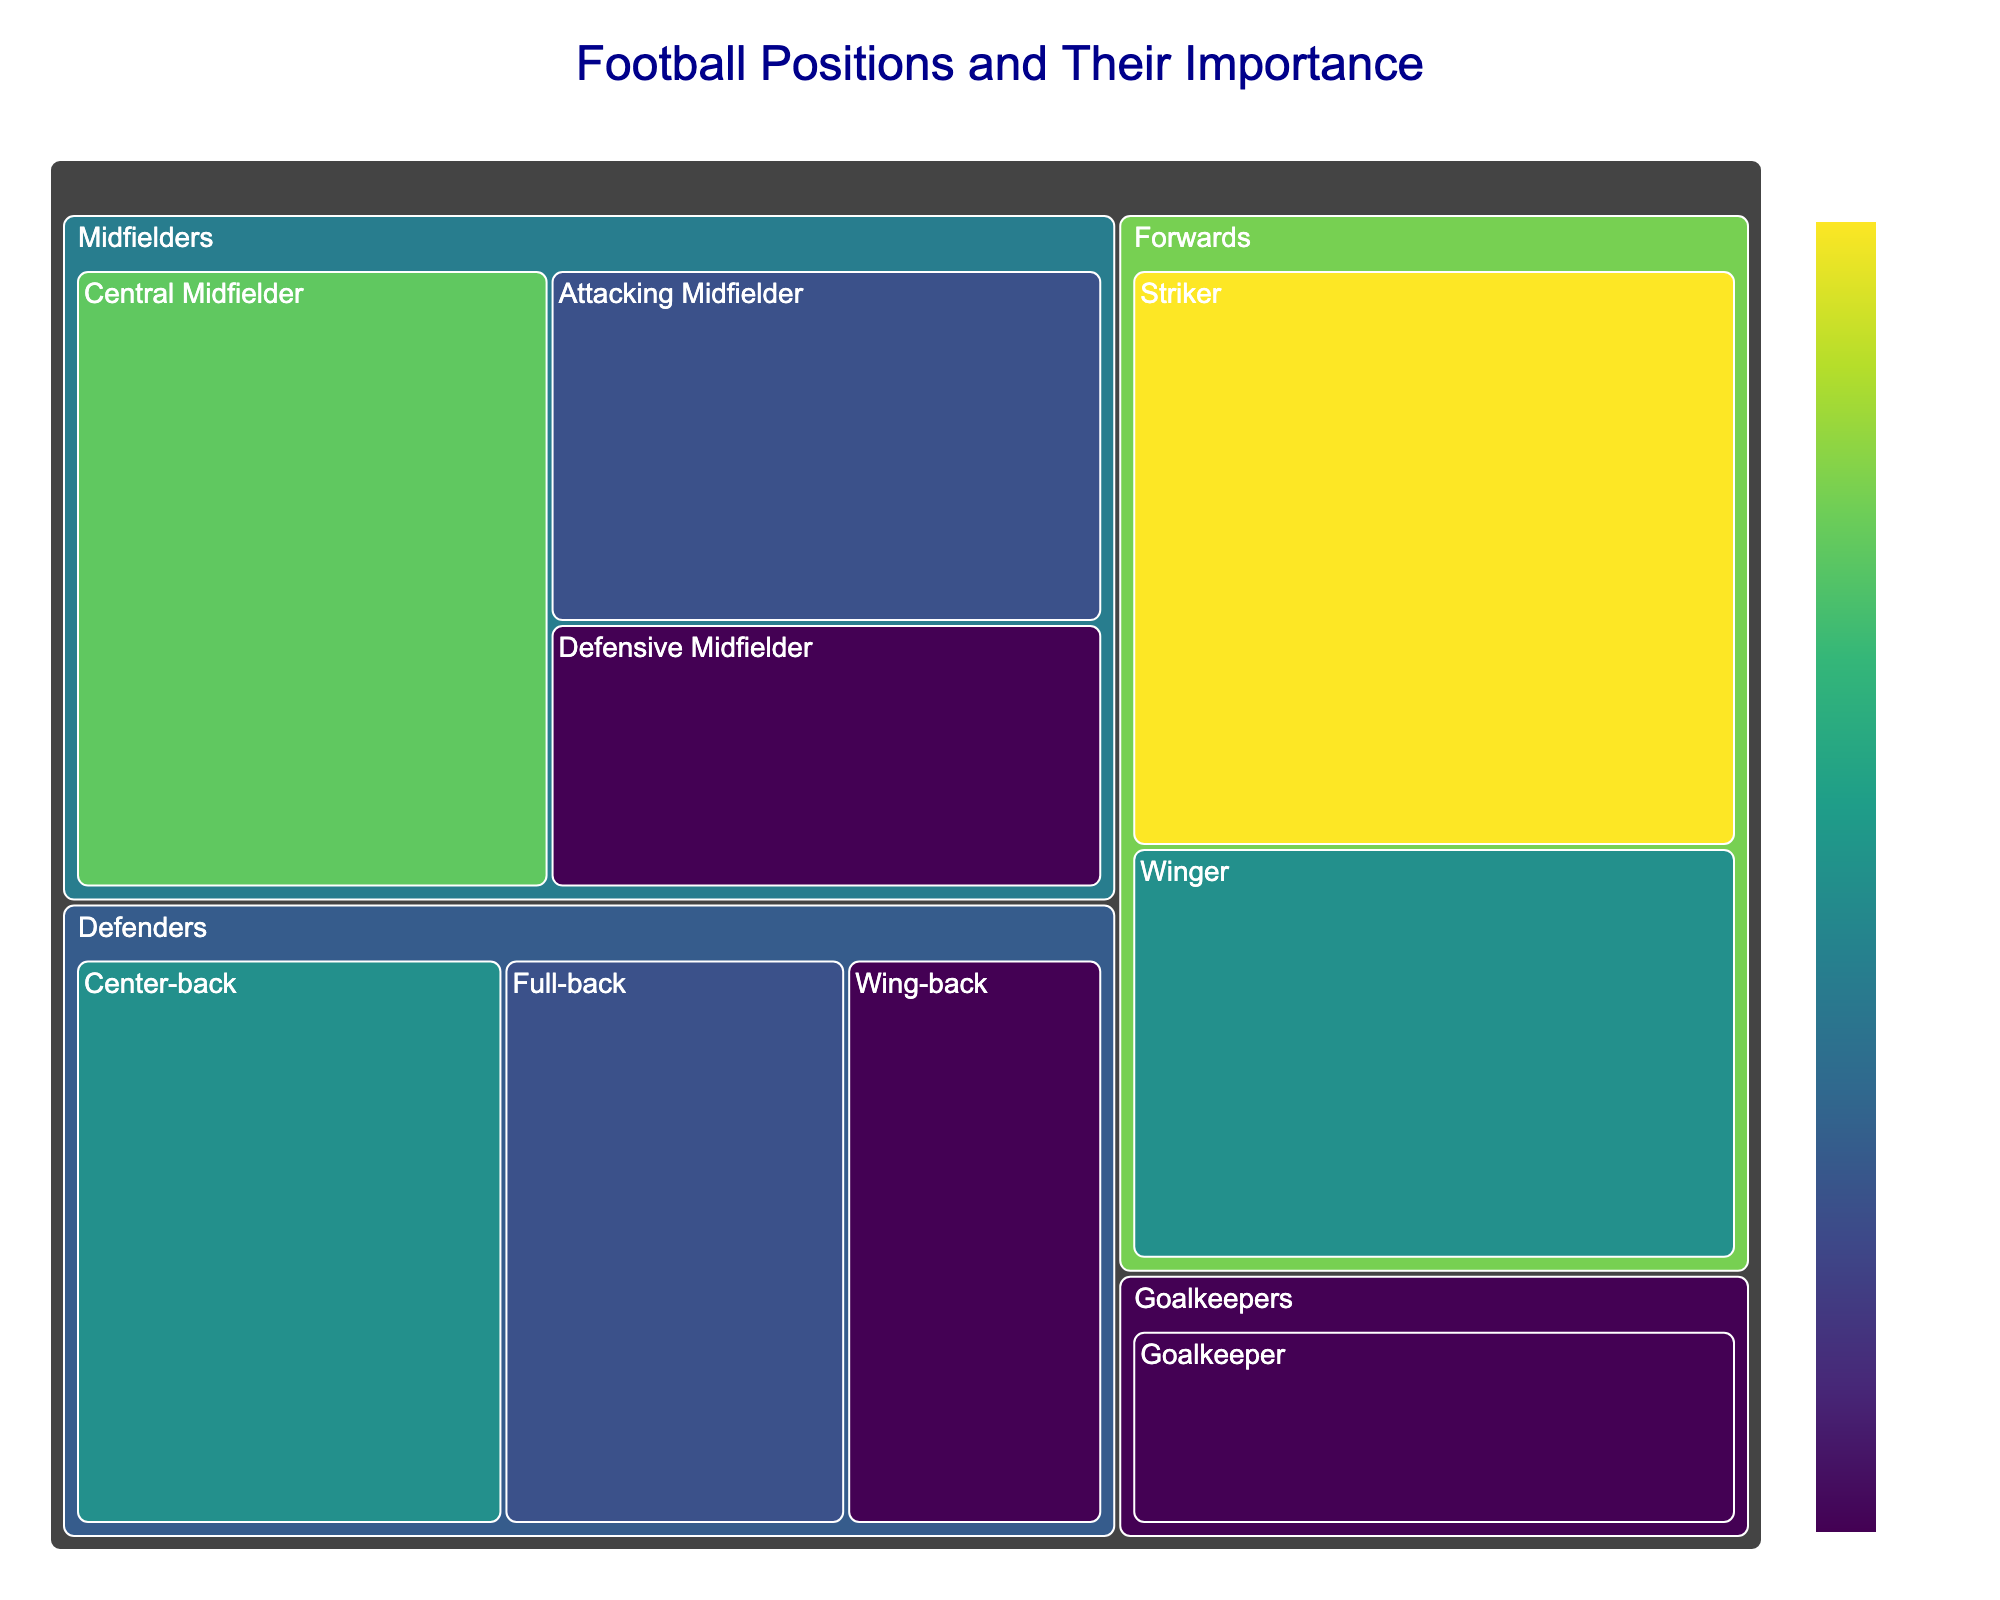What's the title of the treemap? The title of the treemap is generally found at the top center of the figure, indicating the main topic or theme of the visualization. In this case, the title is "Football Positions and Their Importance."
Answer: Football Positions and Their Importance What is the importance value of the Striker role? The importance value is often displayed directly on the visualization. For the Striker role under the Forwards category, the value is labeled as "35."
Answer: 35 How many roles fall under the Midfielders position? By looking at the treemap, we can see the breakdown under the Midfielders category, which includes Central Midfielder, Attacking Midfielder, and Defensive Midfielder. Counting these roles gives us 3.
Answer: 3 What is the combined importance value of all the Defender roles? Sum the importance values of the roles under Defenders: Center-back (25), Full-back (20), and Wing-back (15). The combined value is 25 + 20 + 15 = 60.
Answer: 60 Which position has the least number of roles? By examining the treemap, we can see Goalkeepers have only one role labeled as Goalkeeper. All other positions have more than one.
Answer: Goalkeepers What is the difference in importance between the Striker role and the Wing-back role? The importance value for the Striker is 35 and for the Wing-back is 15. Subtracting 15 from 35 gives us the difference: 35 - 15 = 20.
Answer: 20 Which role within the Forwards has a higher importance, Striker or Winger? Comparing the values directly from the treemap, the Striker has a value of 35 while the Winger has a value of 25. Therefore, Striker has a higher importance.
Answer: Striker What's the total importance value for all the Midfielder roles combined? Sum the importance values for all Midfielder roles: Central Midfielder (30), Attacking Midfielder (20), and Defensive Midfielder (15). The total is 30 + 20 + 15 = 65.
Answer: 65 How is the importance value of the Goalkeeper displayed color-wise? In a treemap with a color scale, lighter colors generally represent lower values while darker colors represent higher values. For the Goalkeeper role with an importance value of 15, it would likely be displayed in a lighter color.
Answer: Lighter color Which position has a role with the highest importance value? By examining the highest values in the treemap, we see that the highest importance value is 35, which belongs to the Striker role under Forwards.
Answer: Forwards 